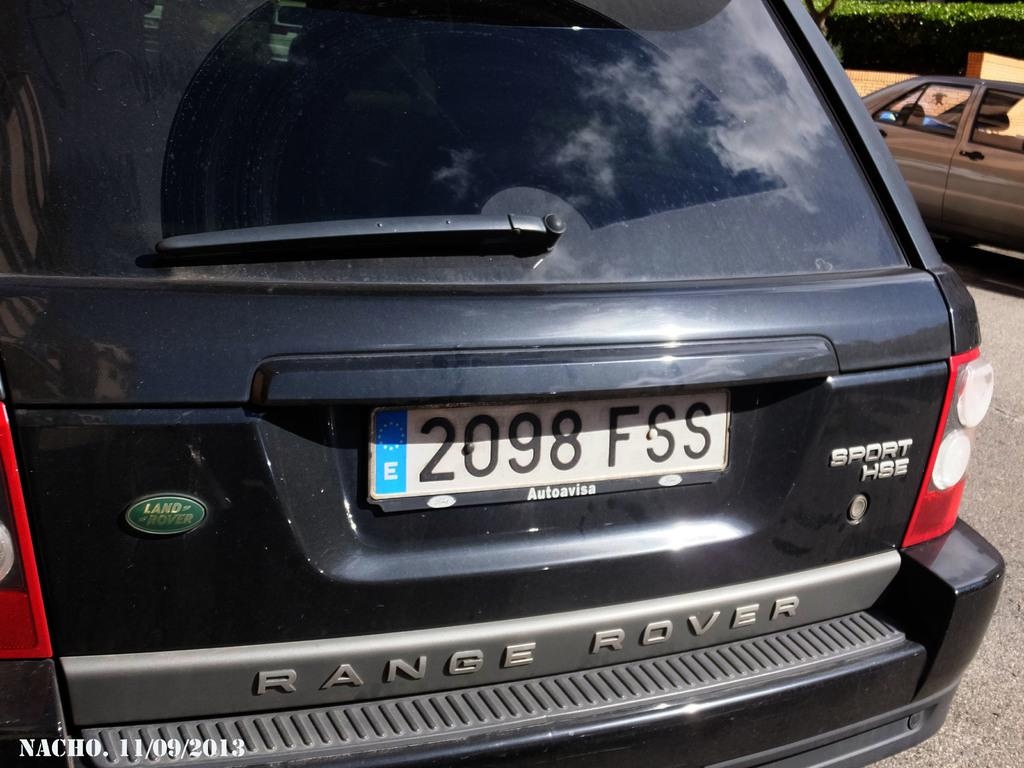<image>
Offer a succinct explanation of the picture presented. A black SUV says Range Rover on the back. 